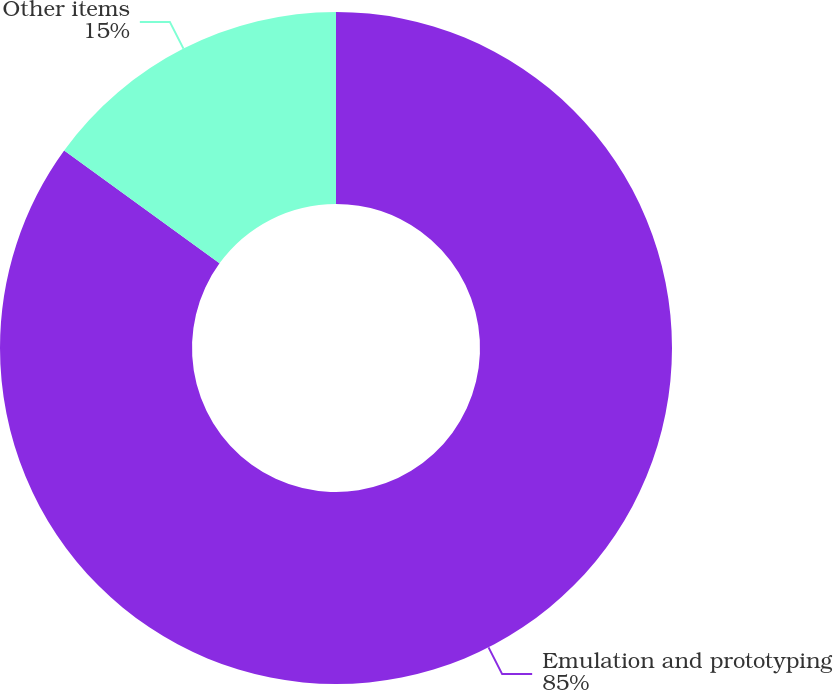Convert chart to OTSL. <chart><loc_0><loc_0><loc_500><loc_500><pie_chart><fcel>Emulation and prototyping<fcel>Other items<nl><fcel>85.0%<fcel>15.0%<nl></chart> 